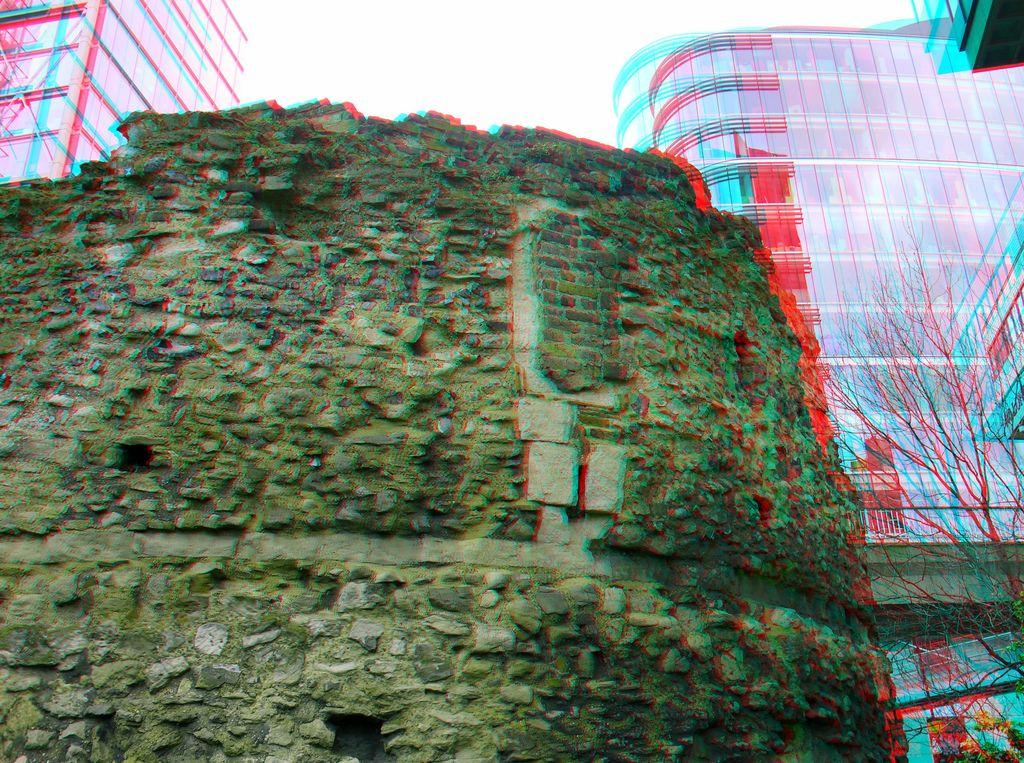What type of structure is visible in the image? There is a wall in the image. What else can be seen in the background of the image? There are background buildings in the image. What type of vegetation is on the right side of the image? There is a tree on the right side of the image. What type of slope can be seen in the image? There is no slope present in the image; it features a wall, background buildings, and a tree. What color are the trousers worn by the tree in the image? There are no trousers present in the image, as trees do not wear clothing. 